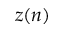<formula> <loc_0><loc_0><loc_500><loc_500>z ( n )</formula> 